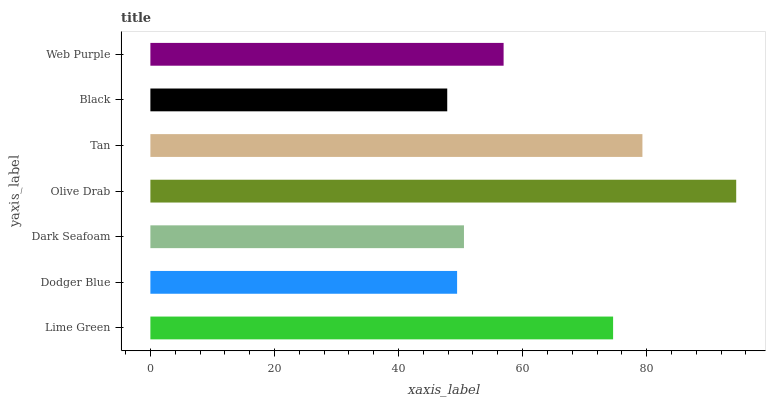Is Black the minimum?
Answer yes or no. Yes. Is Olive Drab the maximum?
Answer yes or no. Yes. Is Dodger Blue the minimum?
Answer yes or no. No. Is Dodger Blue the maximum?
Answer yes or no. No. Is Lime Green greater than Dodger Blue?
Answer yes or no. Yes. Is Dodger Blue less than Lime Green?
Answer yes or no. Yes. Is Dodger Blue greater than Lime Green?
Answer yes or no. No. Is Lime Green less than Dodger Blue?
Answer yes or no. No. Is Web Purple the high median?
Answer yes or no. Yes. Is Web Purple the low median?
Answer yes or no. Yes. Is Tan the high median?
Answer yes or no. No. Is Lime Green the low median?
Answer yes or no. No. 